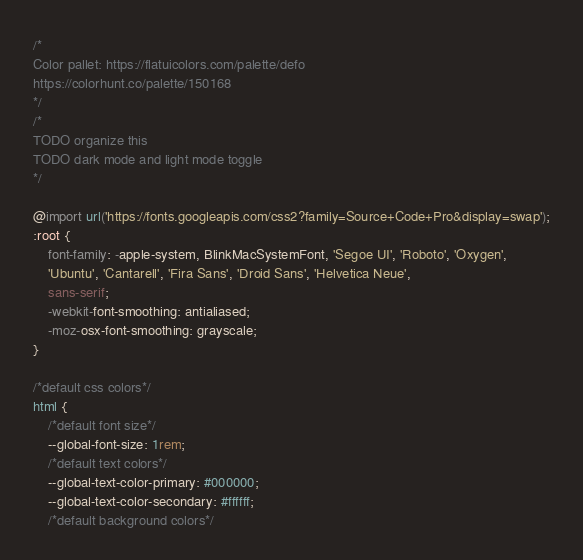<code> <loc_0><loc_0><loc_500><loc_500><_CSS_>/*
Color pallet: https://flatuicolors.com/palette/defo
https://colorhunt.co/palette/150168
*/
/*
TODO organize this
TODO dark mode and light mode toggle
*/

@import url('https://fonts.googleapis.com/css2?family=Source+Code+Pro&display=swap');
:root {
    font-family: -apple-system, BlinkMacSystemFont, 'Segoe UI', 'Roboto', 'Oxygen',
    'Ubuntu', 'Cantarell', 'Fira Sans', 'Droid Sans', 'Helvetica Neue',
    sans-serif;
    -webkit-font-smoothing: antialiased;
    -moz-osx-font-smoothing: grayscale;
}

/*default css colors*/
html {
    /*default font size*/
    --global-font-size: 1rem;
    /*default text colors*/
    --global-text-color-primary: #000000;
    --global-text-color-secondary: #ffffff;
    /*default background colors*/</code> 